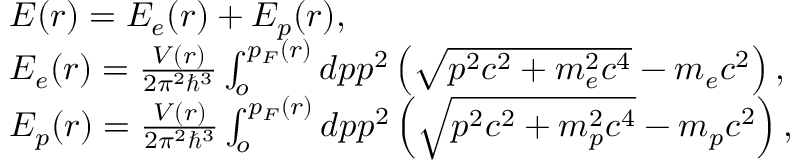<formula> <loc_0><loc_0><loc_500><loc_500>\begin{array} { l } { E ( r ) = E _ { e } ( r ) + E _ { p } ( r ) , } \\ { E _ { e } ( r ) = \frac { V ( r ) } { 2 \pi ^ { 2 } \hbar { ^ } { 3 } } \int _ { o } ^ { p _ { F } ( r ) } d p p ^ { 2 } \left ( \sqrt { p ^ { 2 } c ^ { 2 } + m _ { e } ^ { 2 } c ^ { 4 } } - m _ { e } c ^ { 2 } \right ) , } \\ { E _ { p } ( r ) = \frac { V ( r ) } { 2 \pi ^ { 2 } \hbar { ^ } { 3 } } \int _ { o } ^ { p _ { F } ( r ) } d p p ^ { 2 } \left ( \sqrt { p ^ { 2 } c ^ { 2 } + m _ { p } ^ { 2 } c ^ { 4 } } - m _ { p } c ^ { 2 } \right ) , } \end{array}</formula> 